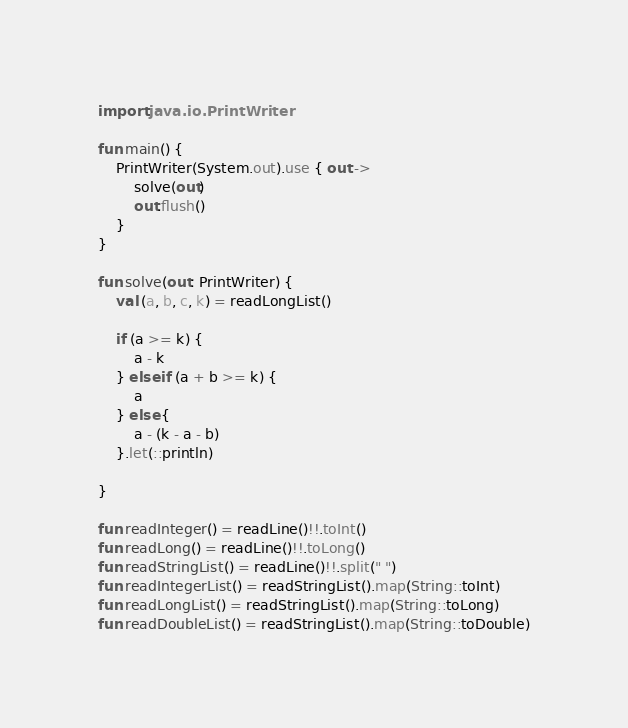Convert code to text. <code><loc_0><loc_0><loc_500><loc_500><_Kotlin_>import java.io.PrintWriter

fun main() {
    PrintWriter(System.out).use { out ->
        solve(out)
        out.flush()
    }
}

fun solve(out: PrintWriter) {
    val (a, b, c, k) = readLongList()

    if (a >= k) {
        a - k
    } else if (a + b >= k) {
        a
    } else {
        a - (k - a - b)   
    }.let(::println)

}

fun readInteger() = readLine()!!.toInt()
fun readLong() = readLine()!!.toLong()
fun readStringList() = readLine()!!.split(" ")
fun readIntegerList() = readStringList().map(String::toInt)
fun readLongList() = readStringList().map(String::toLong)
fun readDoubleList() = readStringList().map(String::toDouble)
</code> 